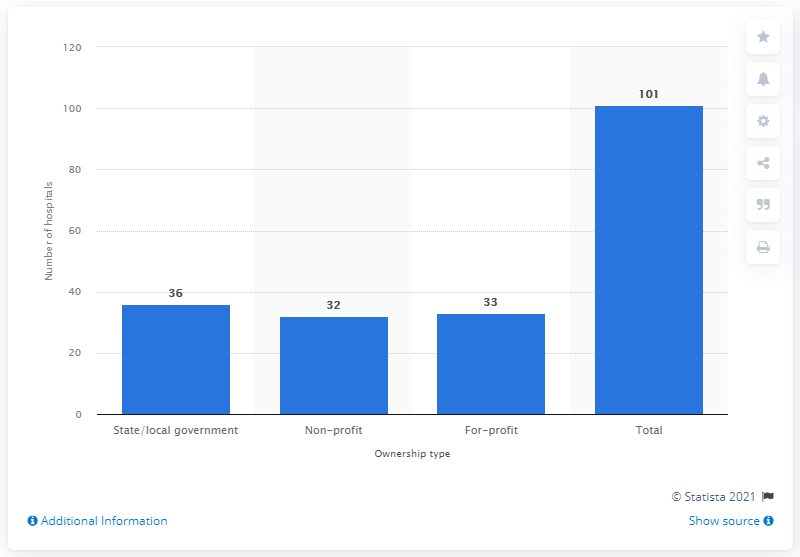Specify some key components in this picture. In 2019, there were 36 hospitals in Alabama that were owned by the state or the local government. 